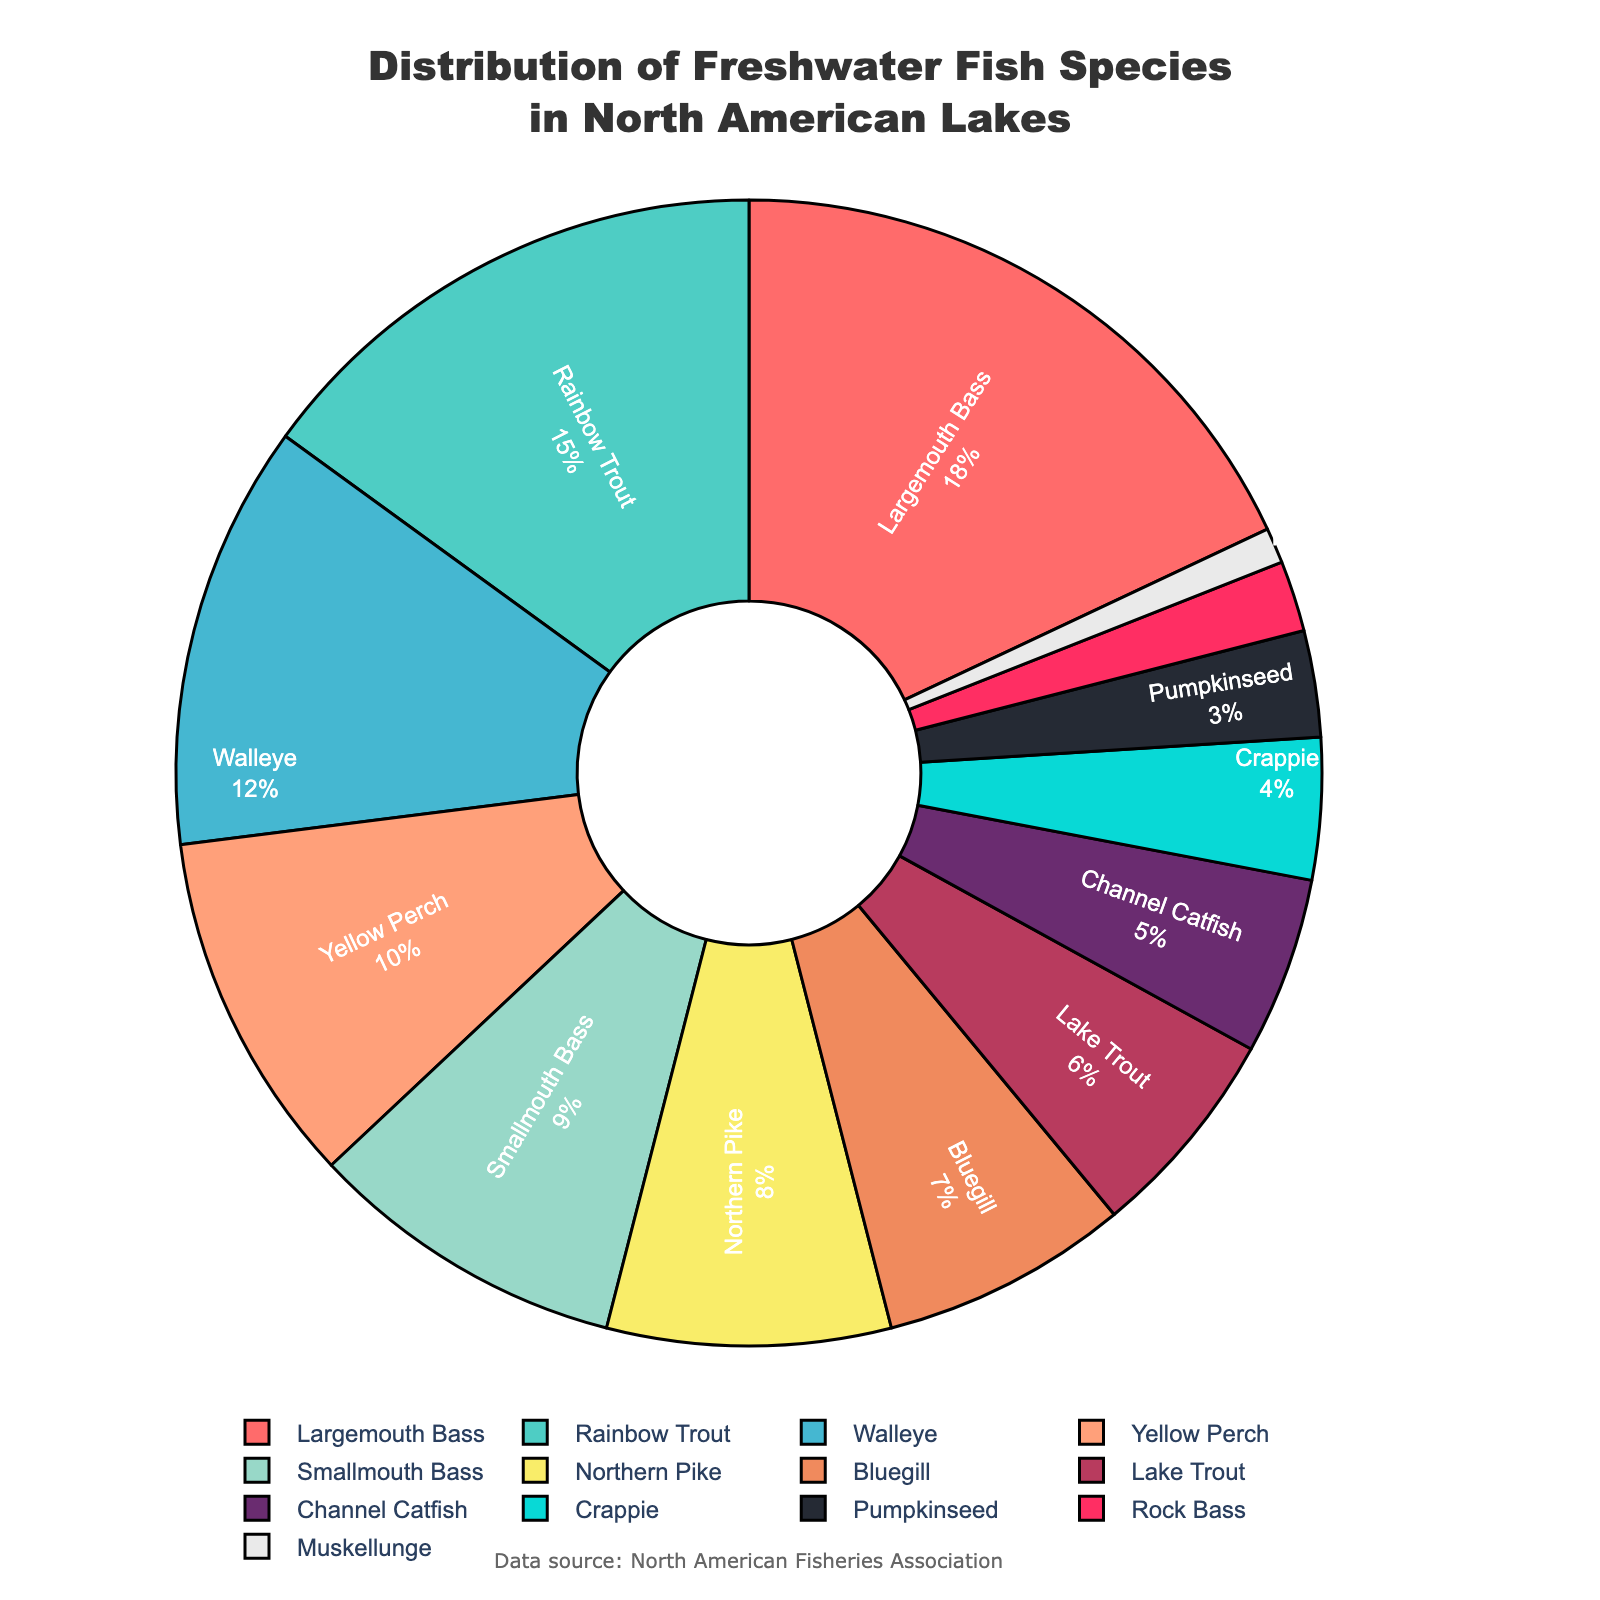Which species has the highest percentage in the distribution? By looking at the pie chart, the segment with the largest proportion corresponds to the Largemouth Bass, which has the highest percentage in the distribution.
Answer: Largemouth Bass Which species has a smaller proportion: Bluegill or Lake Trout? By comparing the sizes of the pie chart segments, Bluegill has a larger proportion than Lake Trout. Therefore, Lake Trout has the smaller proportion.
Answer: Lake Trout What is the combined percentage of Largemouth Bass and Rainbow Trout? Find the percentages for both species (Largemouth Bass is 18%, and Rainbow Trout is 15%) and sum them up: 18% + 15% = 33%.
Answer: 33% Are there more species with a percentage above or below 10%? Count the species with percentages above 10% (Largemouth Bass, Rainbow Trout, and Walleye - 3 species) and below 10% (Yellow Perch, Smallmouth Bass, Northern Pike, Bluegill, Lake Trout, Channel Catfish, Crappie, Pumpkinseed, Rock Bass, Muskellunge - 10 species). There are more species below 10%.
Answer: Below Which species is represented by the green segment of the pie chart? Locate the green segment in the pie chart; it corresponds to the Rainbow Trout.
Answer: Rainbow Trout How much larger is the percentage of Largemouth Bass compared to Smallmouth Bass? Find the percentages for Largemouth Bass (18%) and Smallmouth Bass (9%) and subtract the smaller from the larger: 18% - 9% = 9%.
Answer: 9% What is the median percentage value among all species? Arrange the percentages in ascending order: 1, 2, 3, 4, 5, 6, 7, 8, 9, 10, 12, 15, 18. The middle value (7th in this list) is 7%.
Answer: 7% What visual element indicates the Channel Catfish in the chart? The Channel Catfish is indicated by a section of the pie chart with its specific color and percentage value. In this chart, Channel Catfish has a distinct color and is noted as 5%.
Answer: 5% Among Yellow Perch, Northern Pike, and Bluegill, which species has the highest proportion? Compare the percentages for these species: Yellow Perch (10%), Northern Pike (8%), and Bluegill (7%). Yellow Perch has the highest proportion among the three.
Answer: Yellow Perch 